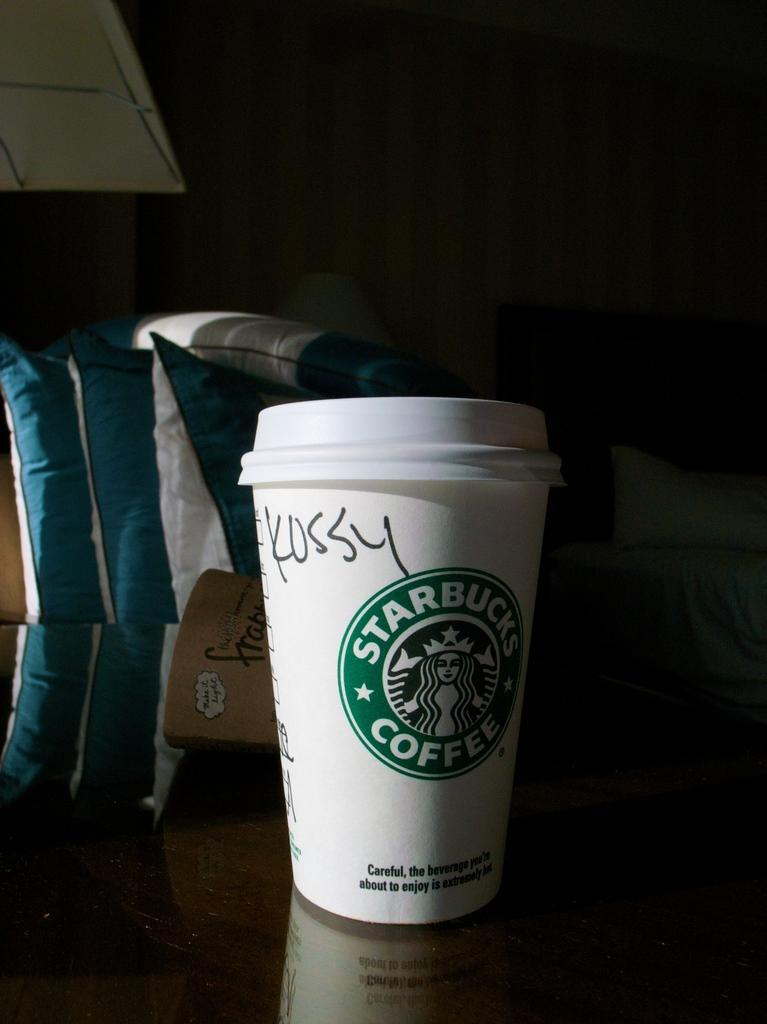What object can be seen in the image that is typically used for holding liquids? There is a cup in the image. What type of soft furnishings are visible in the image? There are pillows in the image. Where are the pillows located in the image? The pillows are on a table. What type of furniture is present in the image that is used for sleeping? There is a bed in the image. Are there any pillows on the bed? Yes, there is a pillow on the bed. What type of metal can be seen in the image? There is no specific metal mentioned or visible in the image. 